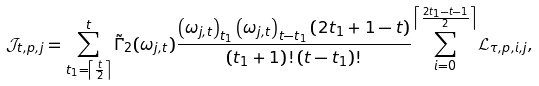<formula> <loc_0><loc_0><loc_500><loc_500>& \mathcal { J } _ { t , p , j } = \sum _ { t _ { 1 } = \left \lceil \frac { t } { 2 } \right \rceil } ^ { t } \tilde { \Gamma } _ { 2 } ( \omega _ { j , t } ) \frac { \left ( \omega _ { j , t } \right ) _ { t _ { 1 } } \left ( \omega _ { j , t } \right ) _ { t - t _ { 1 } } \left ( 2 t _ { 1 } + 1 - t \right ) } { \left ( t _ { 1 } + 1 \right ) ! \left ( t - t _ { 1 } \right ) ! } \sum _ { i = 0 } ^ { \left \lceil \frac { 2 t _ { 1 } - t - 1 } { 2 } \right \rceil } \mathcal { L } _ { \tau , p , i , j } ,</formula> 